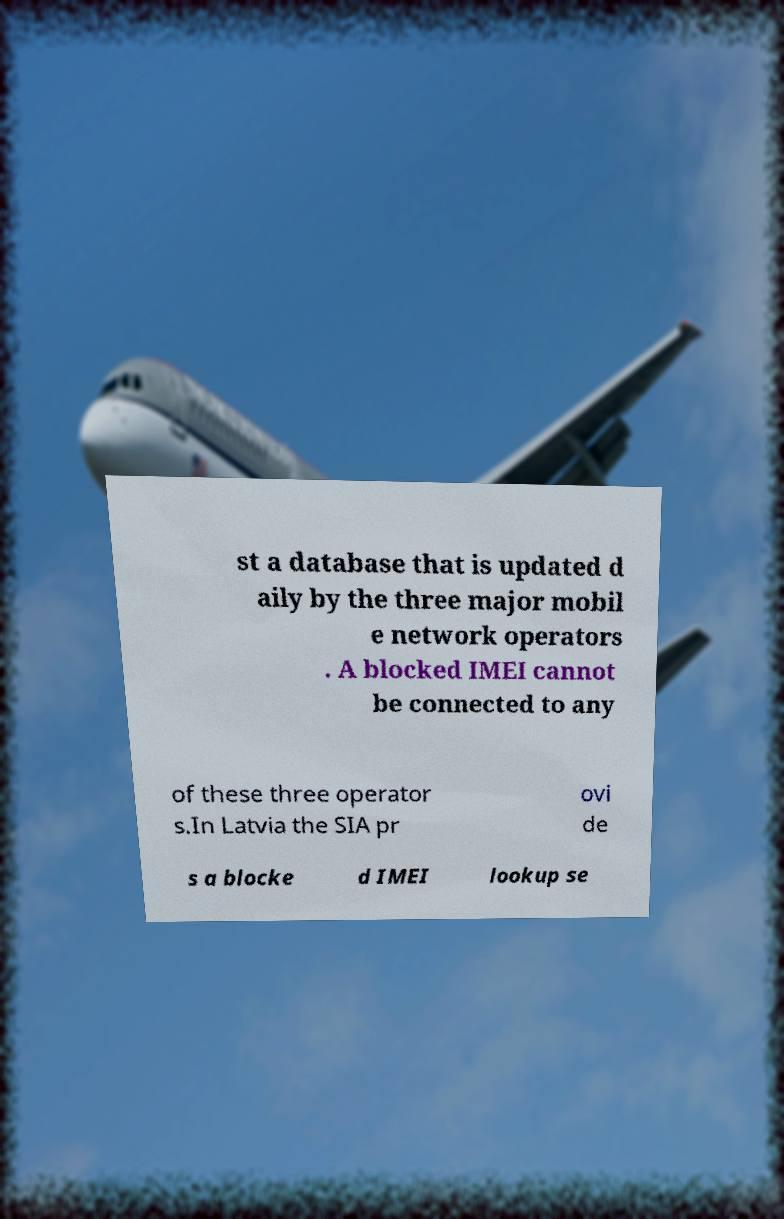What messages or text are displayed in this image? I need them in a readable, typed format. st a database that is updated d aily by the three major mobil e network operators . A blocked IMEI cannot be connected to any of these three operator s.In Latvia the SIA pr ovi de s a blocke d IMEI lookup se 